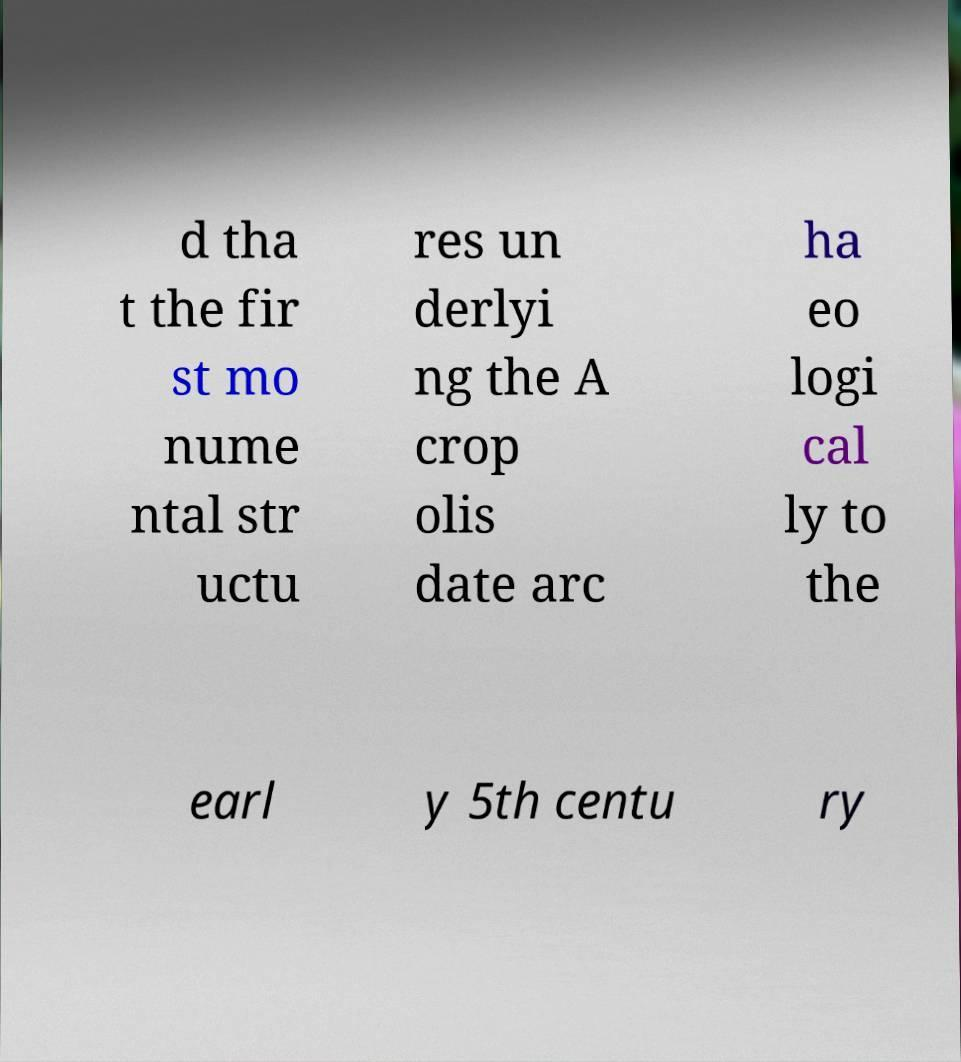Please identify and transcribe the text found in this image. d tha t the fir st mo nume ntal str uctu res un derlyi ng the A crop olis date arc ha eo logi cal ly to the earl y 5th centu ry 